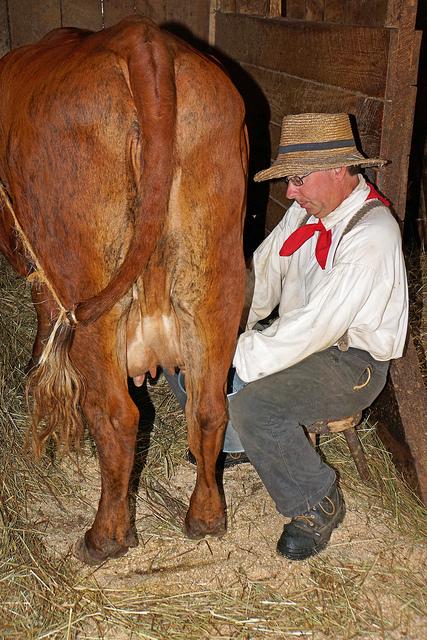Is the cow ready to be milked?
Write a very short answer. Yes. Is this animal male or female?
Quick response, please. Female. Is the man wearing a straw hat?
Keep it brief. Yes. 